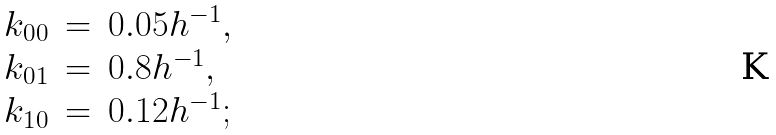<formula> <loc_0><loc_0><loc_500><loc_500>\begin{array} { l c l } k _ { 0 0 } & = & 0 . 0 5 h ^ { - 1 } , \\ k _ { 0 1 } & = & 0 . 8 h ^ { - 1 } , \\ k _ { 1 0 } & = & 0 . 1 2 h ^ { - 1 } ; \\ \end{array}</formula> 